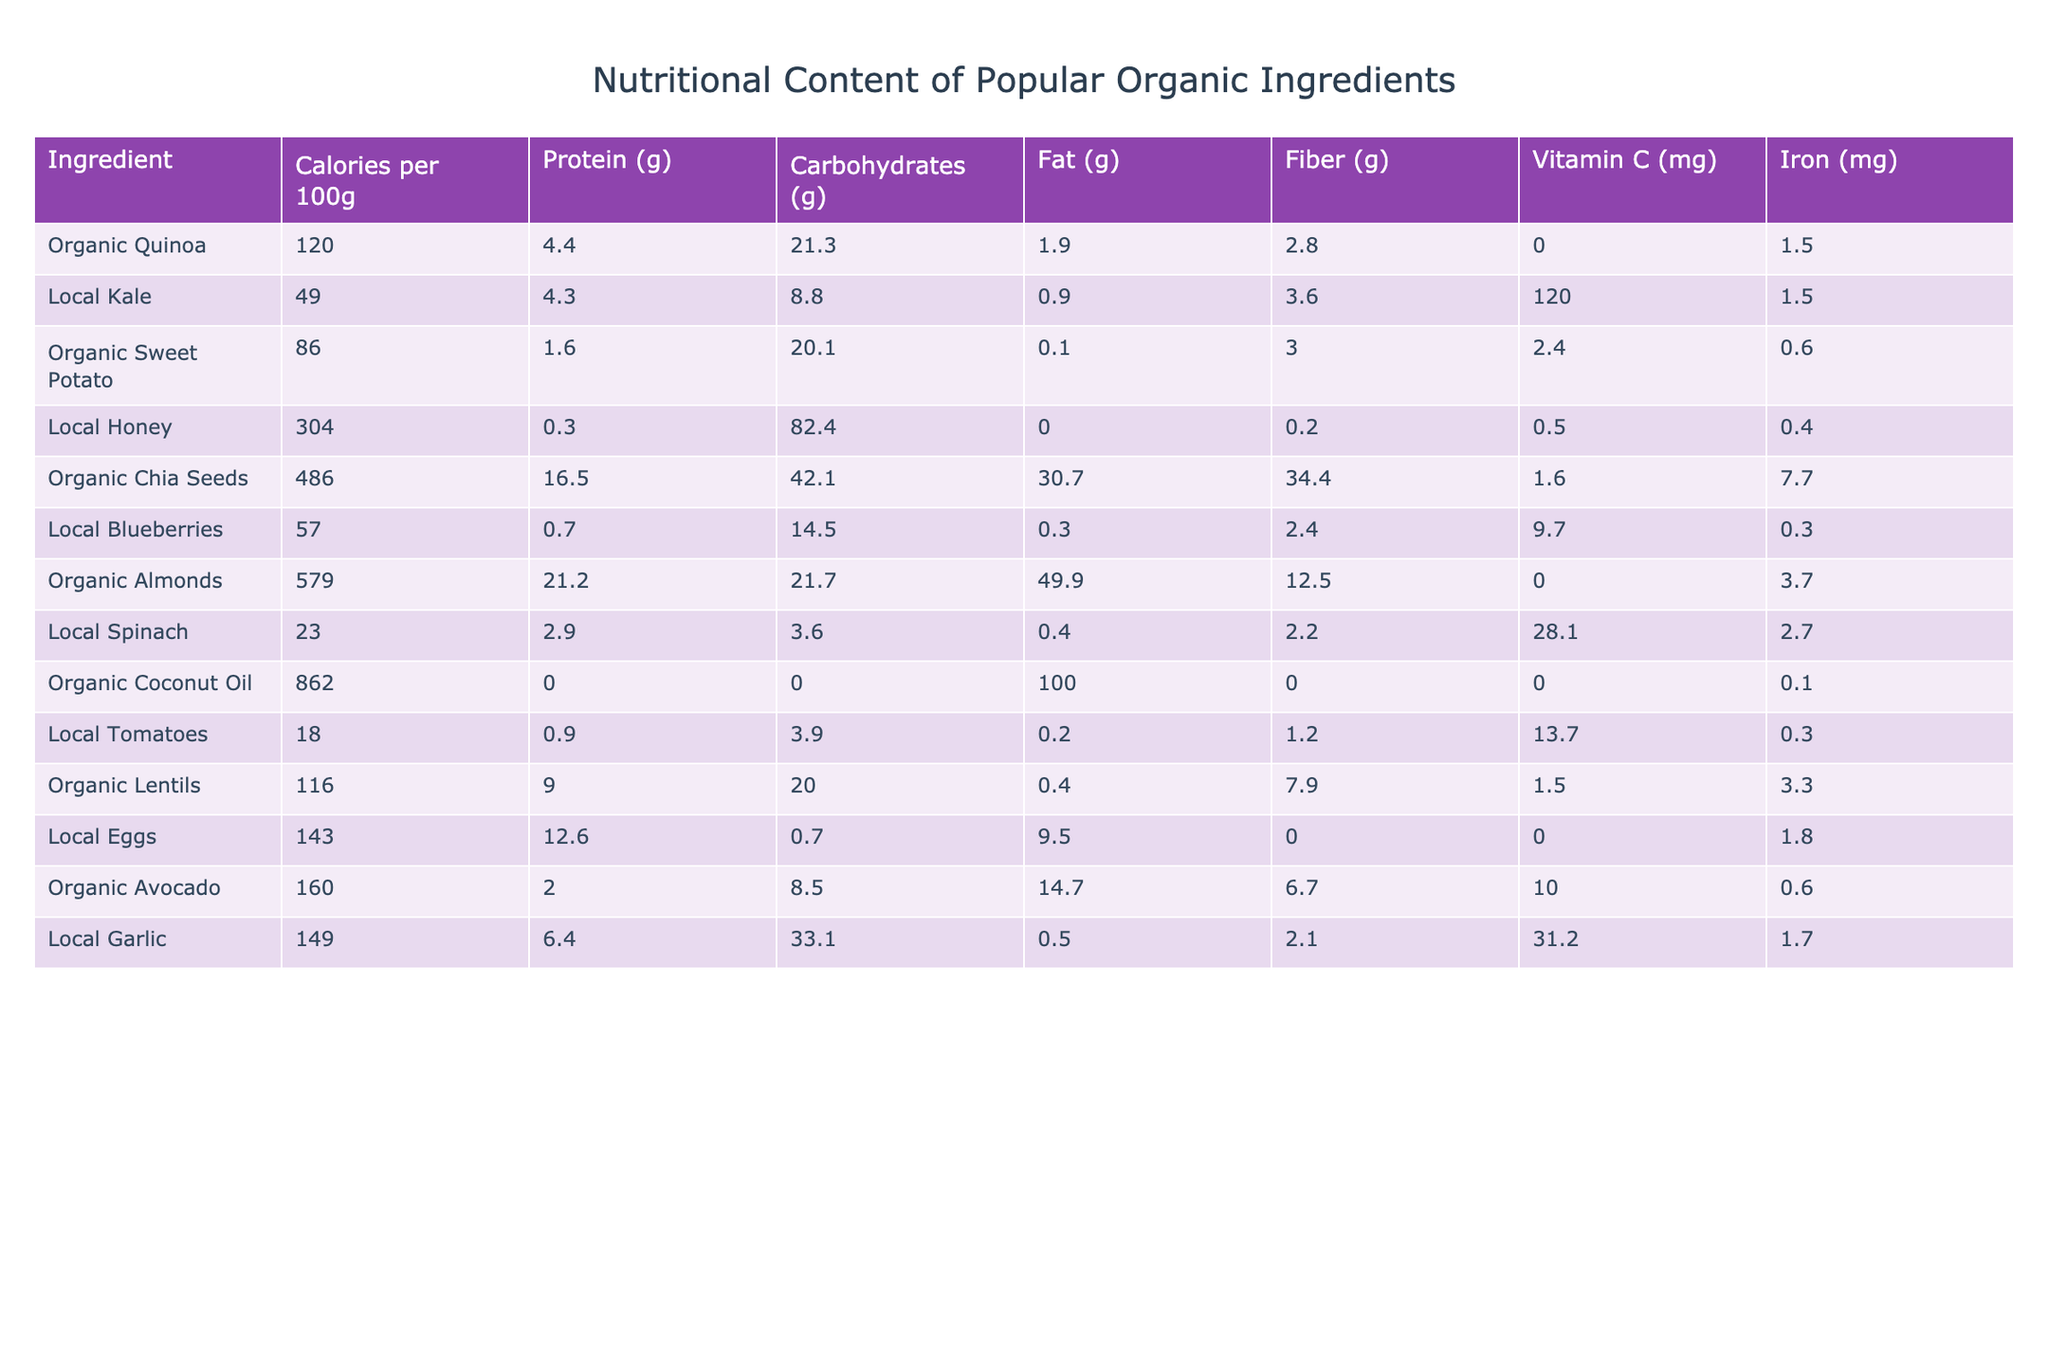What's the calorie content of organic quinoa? According to the table, organic quinoa contains 120 calories per 100 grams, which is directly stated in the "Calories per 100g" column.
Answer: 120 calories Which ingredient has the highest protein content? By comparing the "Protein (g)" column, organic chia seeds have the highest protein content at 16.5 grams per 100 grams.
Answer: Organic Chia Seeds What is the total carbohydrate content of local blueberries and local tomatoes? The carbohydrate content of local blueberries is 14.5 grams and local tomatoes is 3.9 grams. Adding these together gives 14.5 + 3.9 = 18.4 grams.
Answer: 18.4 grams Is organic avocado higher in fat or carbohydrates? Organic avocado has 14.7 grams of fat and 8.5 grams of carbohydrates. Since 14.7 is greater than 8.5, the answer is that it is higher in fat.
Answer: Yes, higher in fat What is the average vitamin C content of local kale, local spinach, and local garlic? The vitamin C content is 120 mg for local kale, 28.1 mg for local spinach, and 31.2 mg for local garlic. The average is (120 + 28.1 + 31.2)/3 = 59.77 mg.
Answer: 59.77 mg Does local honey contain any protein? The protein content listed for local honey is 0.3 grams, which means it contains protein, albeit in a small amount.
Answer: Yes What is the total fiber content of organic lentils and organic chia seeds? Organic lentils have 7.9 grams of fiber and organic chia seeds have 34.4 grams. Adding these gives 7.9 + 34.4 = 42.3 grams of fiber.
Answer: 42.3 grams Which ingredient has the lowest calorie count? Comparing the "Calories per 100g" values, local spinach has the lowest at 23 calories.
Answer: Local Spinach How much more iron does organic chia seeds have compared to local garlic? Organic chia seeds contain 7.7 mg of iron while local garlic contains 1.7 mg. The difference is 7.7 - 1.7 = 6 mg.
Answer: 6 mg What is the total calorie content of organic almonds plus local eggs? Organic almonds have 579 calories and local eggs have 143 calories. Their total is 579 + 143 = 722 calories.
Answer: 722 calories 